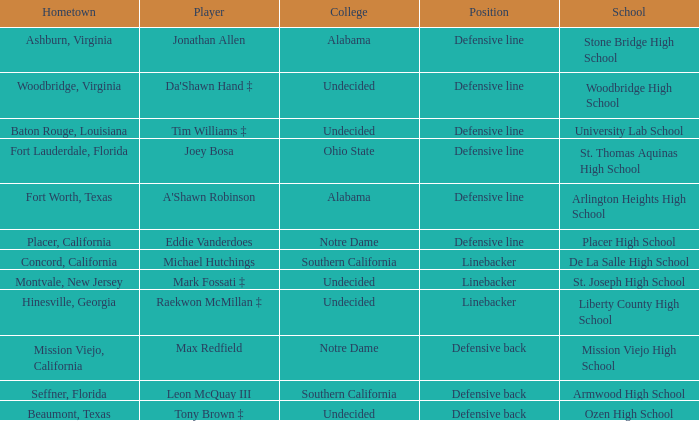What is the position of the player from Beaumont, Texas? Defensive back. 